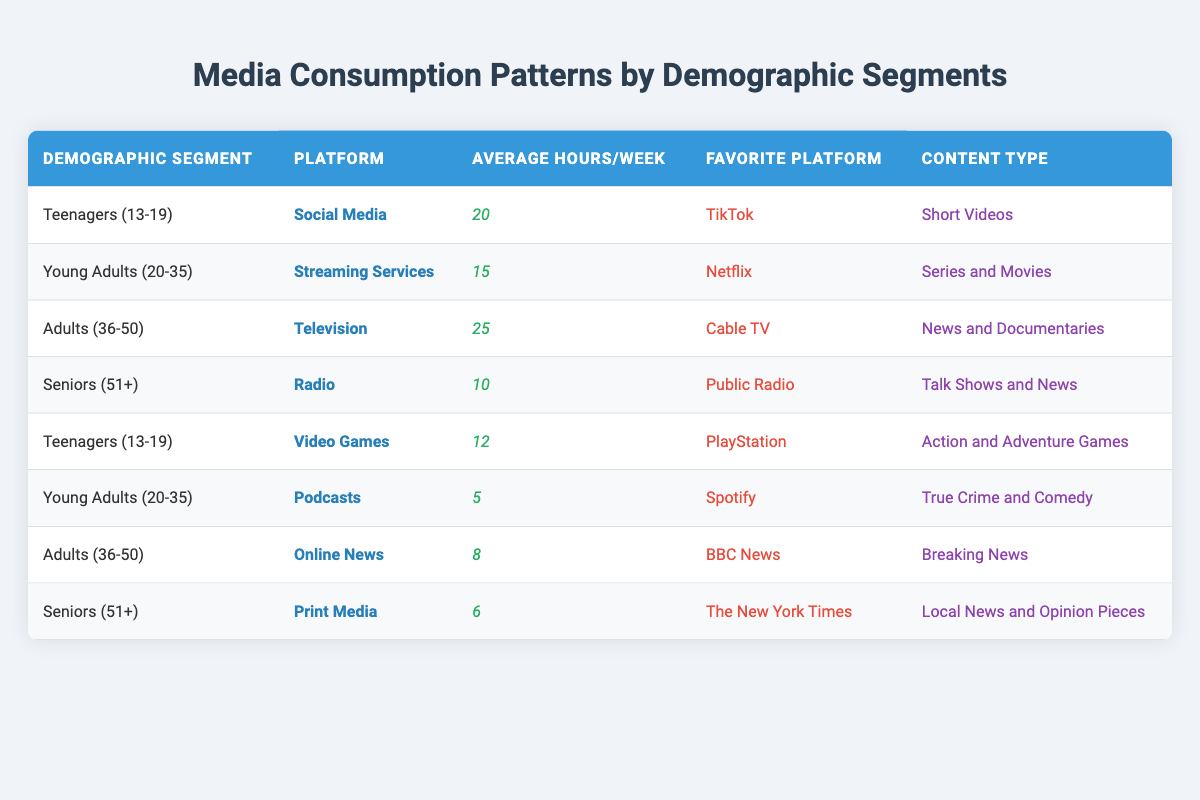What is the average hours per week dedicated to media consumption by Adults (36-50)? Under the Adults (36-50) category, there are two entries: Television with 25 hours and Online News with 8 hours. Adding these gives a total of 33 hours (25 + 8). Since there are 2 platforms, the average is 33/2 = 16.5 hours.
Answer: 16.5 Which demographic segment spends the most hours on media consumption weekly? By reviewing the table, Adults (36-50) spend the most at 25 hours a week for Television, which is higher than all other groups.
Answer: Adults (36-50) Is TikTok the favorite platform for Seniors (51+)? The table shows that Seniors (51+) have Public Radio as their favorite platform. Therefore, TikTok is not the favorite for this demographic.
Answer: No How many hours per week do Teenagers (13-19) spend on Video Games? The table indicates that Teenagers (13-19) spend 12 hours per week on Video Games.
Answer: 12 If you combine the average hours per week for Young Adults (20-35) on Streaming Services and Podcasts, what is the total? Young Adults (20-35) have an average of 15 hours for Streaming Services and 5 hours for Podcasts. Adding these together gives a total of 20 hours (15 + 5).
Answer: 20 Do Adults (36-50) consume more online news than Seniors (51+) consume print media? Adults (36-50) consume 8 hours of Online News, while Seniors (51+) spend only 6 hours on Print Media. Thus, Adults do consume more news online than Seniors consume in print.
Answer: Yes What is the favorite platform for Teenagers (13-19) and how many hours do they spend on Social Media? Teenagers (13-19) have TikTok as their favorite platform and they spend 20 hours per week on Social Media.
Answer: TikTok, 20 How many total hours do Seniors (51+) spend on media consumption weekly across all platforms mentioned? Seniors (51+) engage with Radio for 10 hours and Print Media for 6 hours. Adding these gives a total consumption of 16 hours (10 + 6).
Answer: 16 Which content type do Young Adults (20-35) prefer based on the data? Young Adults (20-35) show a preference for Series and Movies as indicated under the Streaming Services platform.
Answer: Series and Movies 